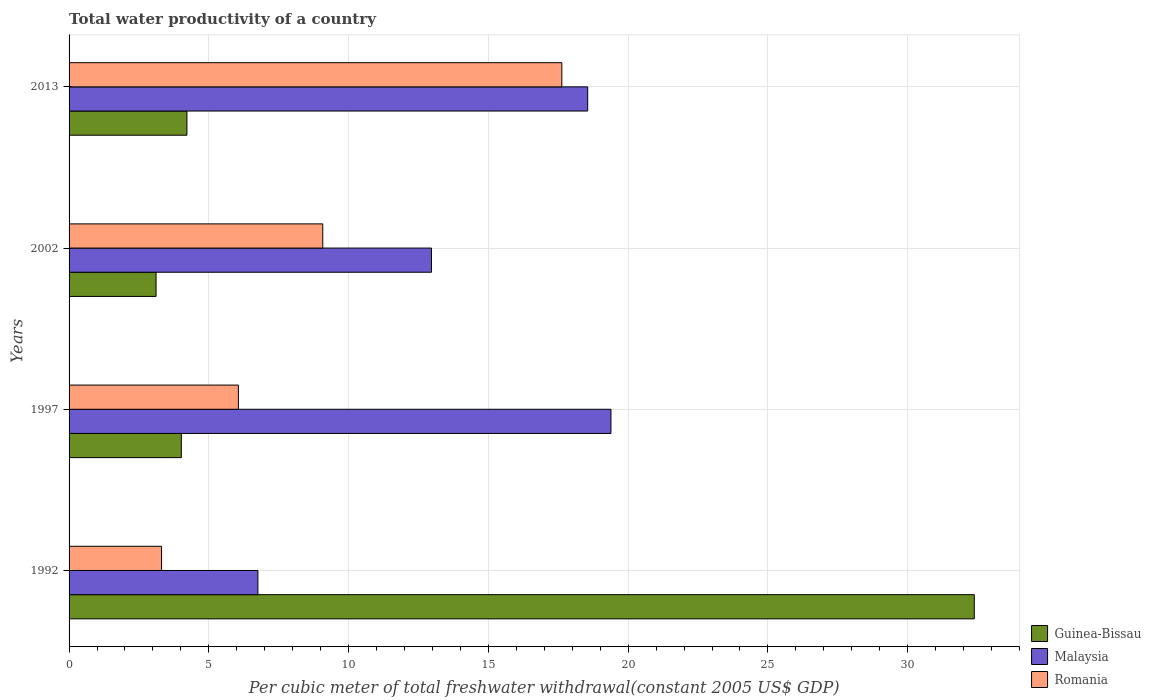How many different coloured bars are there?
Keep it short and to the point. 3. Are the number of bars per tick equal to the number of legend labels?
Your answer should be very brief. Yes. How many bars are there on the 4th tick from the top?
Your answer should be compact. 3. What is the total water productivity in Malaysia in 1997?
Your response must be concise. 19.38. Across all years, what is the maximum total water productivity in Malaysia?
Provide a short and direct response. 19.38. Across all years, what is the minimum total water productivity in Guinea-Bissau?
Your response must be concise. 3.11. In which year was the total water productivity in Romania maximum?
Your response must be concise. 2013. What is the total total water productivity in Malaysia in the graph?
Your answer should be very brief. 57.66. What is the difference between the total water productivity in Romania in 1997 and that in 2002?
Give a very brief answer. -3.02. What is the difference between the total water productivity in Romania in 2013 and the total water productivity in Guinea-Bissau in 2002?
Offer a terse response. 14.52. What is the average total water productivity in Romania per year?
Your answer should be very brief. 9.02. In the year 2002, what is the difference between the total water productivity in Guinea-Bissau and total water productivity in Romania?
Ensure brevity in your answer.  -5.96. In how many years, is the total water productivity in Guinea-Bissau greater than 26 US$?
Make the answer very short. 1. What is the ratio of the total water productivity in Guinea-Bissau in 1992 to that in 1997?
Your response must be concise. 8.06. Is the total water productivity in Guinea-Bissau in 1992 less than that in 2013?
Provide a succinct answer. No. What is the difference between the highest and the second highest total water productivity in Guinea-Bissau?
Make the answer very short. 28.17. What is the difference between the highest and the lowest total water productivity in Guinea-Bissau?
Your answer should be compact. 29.27. Is the sum of the total water productivity in Romania in 1992 and 1997 greater than the maximum total water productivity in Guinea-Bissau across all years?
Provide a succinct answer. No. What does the 3rd bar from the top in 2002 represents?
Provide a succinct answer. Guinea-Bissau. What does the 2nd bar from the bottom in 1992 represents?
Your answer should be compact. Malaysia. Are all the bars in the graph horizontal?
Keep it short and to the point. Yes. What is the difference between two consecutive major ticks on the X-axis?
Provide a short and direct response. 5. Does the graph contain any zero values?
Your response must be concise. No. Does the graph contain grids?
Provide a short and direct response. Yes. Where does the legend appear in the graph?
Your answer should be very brief. Bottom right. How many legend labels are there?
Your response must be concise. 3. How are the legend labels stacked?
Make the answer very short. Vertical. What is the title of the graph?
Your answer should be compact. Total water productivity of a country. What is the label or title of the X-axis?
Provide a short and direct response. Per cubic meter of total freshwater withdrawal(constant 2005 US$ GDP). What is the Per cubic meter of total freshwater withdrawal(constant 2005 US$ GDP) of Guinea-Bissau in 1992?
Make the answer very short. 32.38. What is the Per cubic meter of total freshwater withdrawal(constant 2005 US$ GDP) in Malaysia in 1992?
Provide a succinct answer. 6.76. What is the Per cubic meter of total freshwater withdrawal(constant 2005 US$ GDP) of Romania in 1992?
Your answer should be very brief. 3.31. What is the Per cubic meter of total freshwater withdrawal(constant 2005 US$ GDP) in Guinea-Bissau in 1997?
Provide a succinct answer. 4.02. What is the Per cubic meter of total freshwater withdrawal(constant 2005 US$ GDP) in Malaysia in 1997?
Offer a very short reply. 19.38. What is the Per cubic meter of total freshwater withdrawal(constant 2005 US$ GDP) of Romania in 1997?
Provide a short and direct response. 6.06. What is the Per cubic meter of total freshwater withdrawal(constant 2005 US$ GDP) in Guinea-Bissau in 2002?
Provide a short and direct response. 3.11. What is the Per cubic meter of total freshwater withdrawal(constant 2005 US$ GDP) of Malaysia in 2002?
Offer a terse response. 12.96. What is the Per cubic meter of total freshwater withdrawal(constant 2005 US$ GDP) in Romania in 2002?
Your answer should be compact. 9.08. What is the Per cubic meter of total freshwater withdrawal(constant 2005 US$ GDP) of Guinea-Bissau in 2013?
Keep it short and to the point. 4.22. What is the Per cubic meter of total freshwater withdrawal(constant 2005 US$ GDP) in Malaysia in 2013?
Your answer should be compact. 18.55. What is the Per cubic meter of total freshwater withdrawal(constant 2005 US$ GDP) in Romania in 2013?
Offer a very short reply. 17.63. Across all years, what is the maximum Per cubic meter of total freshwater withdrawal(constant 2005 US$ GDP) in Guinea-Bissau?
Ensure brevity in your answer.  32.38. Across all years, what is the maximum Per cubic meter of total freshwater withdrawal(constant 2005 US$ GDP) of Malaysia?
Your answer should be compact. 19.38. Across all years, what is the maximum Per cubic meter of total freshwater withdrawal(constant 2005 US$ GDP) in Romania?
Provide a succinct answer. 17.63. Across all years, what is the minimum Per cubic meter of total freshwater withdrawal(constant 2005 US$ GDP) in Guinea-Bissau?
Keep it short and to the point. 3.11. Across all years, what is the minimum Per cubic meter of total freshwater withdrawal(constant 2005 US$ GDP) in Malaysia?
Make the answer very short. 6.76. Across all years, what is the minimum Per cubic meter of total freshwater withdrawal(constant 2005 US$ GDP) in Romania?
Offer a very short reply. 3.31. What is the total Per cubic meter of total freshwater withdrawal(constant 2005 US$ GDP) of Guinea-Bissau in the graph?
Offer a very short reply. 43.73. What is the total Per cubic meter of total freshwater withdrawal(constant 2005 US$ GDP) in Malaysia in the graph?
Offer a very short reply. 57.66. What is the total Per cubic meter of total freshwater withdrawal(constant 2005 US$ GDP) of Romania in the graph?
Offer a terse response. 36.07. What is the difference between the Per cubic meter of total freshwater withdrawal(constant 2005 US$ GDP) in Guinea-Bissau in 1992 and that in 1997?
Provide a succinct answer. 28.37. What is the difference between the Per cubic meter of total freshwater withdrawal(constant 2005 US$ GDP) in Malaysia in 1992 and that in 1997?
Ensure brevity in your answer.  -12.63. What is the difference between the Per cubic meter of total freshwater withdrawal(constant 2005 US$ GDP) in Romania in 1992 and that in 1997?
Make the answer very short. -2.75. What is the difference between the Per cubic meter of total freshwater withdrawal(constant 2005 US$ GDP) of Guinea-Bissau in 1992 and that in 2002?
Make the answer very short. 29.27. What is the difference between the Per cubic meter of total freshwater withdrawal(constant 2005 US$ GDP) in Malaysia in 1992 and that in 2002?
Offer a very short reply. -6.21. What is the difference between the Per cubic meter of total freshwater withdrawal(constant 2005 US$ GDP) of Romania in 1992 and that in 2002?
Offer a very short reply. -5.77. What is the difference between the Per cubic meter of total freshwater withdrawal(constant 2005 US$ GDP) of Guinea-Bissau in 1992 and that in 2013?
Give a very brief answer. 28.17. What is the difference between the Per cubic meter of total freshwater withdrawal(constant 2005 US$ GDP) of Malaysia in 1992 and that in 2013?
Give a very brief answer. -11.8. What is the difference between the Per cubic meter of total freshwater withdrawal(constant 2005 US$ GDP) of Romania in 1992 and that in 2013?
Offer a very short reply. -14.32. What is the difference between the Per cubic meter of total freshwater withdrawal(constant 2005 US$ GDP) of Guinea-Bissau in 1997 and that in 2002?
Your answer should be very brief. 0.9. What is the difference between the Per cubic meter of total freshwater withdrawal(constant 2005 US$ GDP) of Malaysia in 1997 and that in 2002?
Offer a very short reply. 6.42. What is the difference between the Per cubic meter of total freshwater withdrawal(constant 2005 US$ GDP) of Romania in 1997 and that in 2002?
Ensure brevity in your answer.  -3.02. What is the difference between the Per cubic meter of total freshwater withdrawal(constant 2005 US$ GDP) of Guinea-Bissau in 1997 and that in 2013?
Provide a succinct answer. -0.2. What is the difference between the Per cubic meter of total freshwater withdrawal(constant 2005 US$ GDP) in Malaysia in 1997 and that in 2013?
Ensure brevity in your answer.  0.83. What is the difference between the Per cubic meter of total freshwater withdrawal(constant 2005 US$ GDP) of Romania in 1997 and that in 2013?
Your answer should be compact. -11.57. What is the difference between the Per cubic meter of total freshwater withdrawal(constant 2005 US$ GDP) in Guinea-Bissau in 2002 and that in 2013?
Keep it short and to the point. -1.1. What is the difference between the Per cubic meter of total freshwater withdrawal(constant 2005 US$ GDP) of Malaysia in 2002 and that in 2013?
Your answer should be compact. -5.59. What is the difference between the Per cubic meter of total freshwater withdrawal(constant 2005 US$ GDP) of Romania in 2002 and that in 2013?
Ensure brevity in your answer.  -8.55. What is the difference between the Per cubic meter of total freshwater withdrawal(constant 2005 US$ GDP) in Guinea-Bissau in 1992 and the Per cubic meter of total freshwater withdrawal(constant 2005 US$ GDP) in Malaysia in 1997?
Provide a short and direct response. 13. What is the difference between the Per cubic meter of total freshwater withdrawal(constant 2005 US$ GDP) in Guinea-Bissau in 1992 and the Per cubic meter of total freshwater withdrawal(constant 2005 US$ GDP) in Romania in 1997?
Provide a succinct answer. 26.33. What is the difference between the Per cubic meter of total freshwater withdrawal(constant 2005 US$ GDP) of Malaysia in 1992 and the Per cubic meter of total freshwater withdrawal(constant 2005 US$ GDP) of Romania in 1997?
Your answer should be very brief. 0.7. What is the difference between the Per cubic meter of total freshwater withdrawal(constant 2005 US$ GDP) of Guinea-Bissau in 1992 and the Per cubic meter of total freshwater withdrawal(constant 2005 US$ GDP) of Malaysia in 2002?
Keep it short and to the point. 19.42. What is the difference between the Per cubic meter of total freshwater withdrawal(constant 2005 US$ GDP) in Guinea-Bissau in 1992 and the Per cubic meter of total freshwater withdrawal(constant 2005 US$ GDP) in Romania in 2002?
Give a very brief answer. 23.31. What is the difference between the Per cubic meter of total freshwater withdrawal(constant 2005 US$ GDP) of Malaysia in 1992 and the Per cubic meter of total freshwater withdrawal(constant 2005 US$ GDP) of Romania in 2002?
Keep it short and to the point. -2.32. What is the difference between the Per cubic meter of total freshwater withdrawal(constant 2005 US$ GDP) of Guinea-Bissau in 1992 and the Per cubic meter of total freshwater withdrawal(constant 2005 US$ GDP) of Malaysia in 2013?
Provide a short and direct response. 13.83. What is the difference between the Per cubic meter of total freshwater withdrawal(constant 2005 US$ GDP) of Guinea-Bissau in 1992 and the Per cubic meter of total freshwater withdrawal(constant 2005 US$ GDP) of Romania in 2013?
Make the answer very short. 14.75. What is the difference between the Per cubic meter of total freshwater withdrawal(constant 2005 US$ GDP) in Malaysia in 1992 and the Per cubic meter of total freshwater withdrawal(constant 2005 US$ GDP) in Romania in 2013?
Your response must be concise. -10.87. What is the difference between the Per cubic meter of total freshwater withdrawal(constant 2005 US$ GDP) in Guinea-Bissau in 1997 and the Per cubic meter of total freshwater withdrawal(constant 2005 US$ GDP) in Malaysia in 2002?
Ensure brevity in your answer.  -8.95. What is the difference between the Per cubic meter of total freshwater withdrawal(constant 2005 US$ GDP) in Guinea-Bissau in 1997 and the Per cubic meter of total freshwater withdrawal(constant 2005 US$ GDP) in Romania in 2002?
Ensure brevity in your answer.  -5.06. What is the difference between the Per cubic meter of total freshwater withdrawal(constant 2005 US$ GDP) of Malaysia in 1997 and the Per cubic meter of total freshwater withdrawal(constant 2005 US$ GDP) of Romania in 2002?
Offer a terse response. 10.31. What is the difference between the Per cubic meter of total freshwater withdrawal(constant 2005 US$ GDP) of Guinea-Bissau in 1997 and the Per cubic meter of total freshwater withdrawal(constant 2005 US$ GDP) of Malaysia in 2013?
Your answer should be very brief. -14.54. What is the difference between the Per cubic meter of total freshwater withdrawal(constant 2005 US$ GDP) in Guinea-Bissau in 1997 and the Per cubic meter of total freshwater withdrawal(constant 2005 US$ GDP) in Romania in 2013?
Ensure brevity in your answer.  -13.61. What is the difference between the Per cubic meter of total freshwater withdrawal(constant 2005 US$ GDP) of Malaysia in 1997 and the Per cubic meter of total freshwater withdrawal(constant 2005 US$ GDP) of Romania in 2013?
Offer a very short reply. 1.76. What is the difference between the Per cubic meter of total freshwater withdrawal(constant 2005 US$ GDP) in Guinea-Bissau in 2002 and the Per cubic meter of total freshwater withdrawal(constant 2005 US$ GDP) in Malaysia in 2013?
Ensure brevity in your answer.  -15.44. What is the difference between the Per cubic meter of total freshwater withdrawal(constant 2005 US$ GDP) in Guinea-Bissau in 2002 and the Per cubic meter of total freshwater withdrawal(constant 2005 US$ GDP) in Romania in 2013?
Offer a very short reply. -14.52. What is the difference between the Per cubic meter of total freshwater withdrawal(constant 2005 US$ GDP) of Malaysia in 2002 and the Per cubic meter of total freshwater withdrawal(constant 2005 US$ GDP) of Romania in 2013?
Your answer should be compact. -4.66. What is the average Per cubic meter of total freshwater withdrawal(constant 2005 US$ GDP) in Guinea-Bissau per year?
Keep it short and to the point. 10.93. What is the average Per cubic meter of total freshwater withdrawal(constant 2005 US$ GDP) in Malaysia per year?
Provide a short and direct response. 14.41. What is the average Per cubic meter of total freshwater withdrawal(constant 2005 US$ GDP) in Romania per year?
Provide a short and direct response. 9.02. In the year 1992, what is the difference between the Per cubic meter of total freshwater withdrawal(constant 2005 US$ GDP) of Guinea-Bissau and Per cubic meter of total freshwater withdrawal(constant 2005 US$ GDP) of Malaysia?
Provide a short and direct response. 25.63. In the year 1992, what is the difference between the Per cubic meter of total freshwater withdrawal(constant 2005 US$ GDP) of Guinea-Bissau and Per cubic meter of total freshwater withdrawal(constant 2005 US$ GDP) of Romania?
Offer a very short reply. 29.07. In the year 1992, what is the difference between the Per cubic meter of total freshwater withdrawal(constant 2005 US$ GDP) in Malaysia and Per cubic meter of total freshwater withdrawal(constant 2005 US$ GDP) in Romania?
Offer a terse response. 3.45. In the year 1997, what is the difference between the Per cubic meter of total freshwater withdrawal(constant 2005 US$ GDP) in Guinea-Bissau and Per cubic meter of total freshwater withdrawal(constant 2005 US$ GDP) in Malaysia?
Keep it short and to the point. -15.37. In the year 1997, what is the difference between the Per cubic meter of total freshwater withdrawal(constant 2005 US$ GDP) of Guinea-Bissau and Per cubic meter of total freshwater withdrawal(constant 2005 US$ GDP) of Romania?
Offer a terse response. -2.04. In the year 1997, what is the difference between the Per cubic meter of total freshwater withdrawal(constant 2005 US$ GDP) in Malaysia and Per cubic meter of total freshwater withdrawal(constant 2005 US$ GDP) in Romania?
Keep it short and to the point. 13.33. In the year 2002, what is the difference between the Per cubic meter of total freshwater withdrawal(constant 2005 US$ GDP) of Guinea-Bissau and Per cubic meter of total freshwater withdrawal(constant 2005 US$ GDP) of Malaysia?
Your response must be concise. -9.85. In the year 2002, what is the difference between the Per cubic meter of total freshwater withdrawal(constant 2005 US$ GDP) in Guinea-Bissau and Per cubic meter of total freshwater withdrawal(constant 2005 US$ GDP) in Romania?
Provide a short and direct response. -5.96. In the year 2002, what is the difference between the Per cubic meter of total freshwater withdrawal(constant 2005 US$ GDP) of Malaysia and Per cubic meter of total freshwater withdrawal(constant 2005 US$ GDP) of Romania?
Make the answer very short. 3.89. In the year 2013, what is the difference between the Per cubic meter of total freshwater withdrawal(constant 2005 US$ GDP) in Guinea-Bissau and Per cubic meter of total freshwater withdrawal(constant 2005 US$ GDP) in Malaysia?
Give a very brief answer. -14.34. In the year 2013, what is the difference between the Per cubic meter of total freshwater withdrawal(constant 2005 US$ GDP) in Guinea-Bissau and Per cubic meter of total freshwater withdrawal(constant 2005 US$ GDP) in Romania?
Provide a short and direct response. -13.41. In the year 2013, what is the difference between the Per cubic meter of total freshwater withdrawal(constant 2005 US$ GDP) in Malaysia and Per cubic meter of total freshwater withdrawal(constant 2005 US$ GDP) in Romania?
Offer a terse response. 0.92. What is the ratio of the Per cubic meter of total freshwater withdrawal(constant 2005 US$ GDP) in Guinea-Bissau in 1992 to that in 1997?
Your answer should be very brief. 8.06. What is the ratio of the Per cubic meter of total freshwater withdrawal(constant 2005 US$ GDP) in Malaysia in 1992 to that in 1997?
Ensure brevity in your answer.  0.35. What is the ratio of the Per cubic meter of total freshwater withdrawal(constant 2005 US$ GDP) in Romania in 1992 to that in 1997?
Keep it short and to the point. 0.55. What is the ratio of the Per cubic meter of total freshwater withdrawal(constant 2005 US$ GDP) in Guinea-Bissau in 1992 to that in 2002?
Provide a succinct answer. 10.41. What is the ratio of the Per cubic meter of total freshwater withdrawal(constant 2005 US$ GDP) of Malaysia in 1992 to that in 2002?
Your response must be concise. 0.52. What is the ratio of the Per cubic meter of total freshwater withdrawal(constant 2005 US$ GDP) of Romania in 1992 to that in 2002?
Your answer should be very brief. 0.36. What is the ratio of the Per cubic meter of total freshwater withdrawal(constant 2005 US$ GDP) of Guinea-Bissau in 1992 to that in 2013?
Your answer should be compact. 7.68. What is the ratio of the Per cubic meter of total freshwater withdrawal(constant 2005 US$ GDP) in Malaysia in 1992 to that in 2013?
Your answer should be very brief. 0.36. What is the ratio of the Per cubic meter of total freshwater withdrawal(constant 2005 US$ GDP) in Romania in 1992 to that in 2013?
Your answer should be compact. 0.19. What is the ratio of the Per cubic meter of total freshwater withdrawal(constant 2005 US$ GDP) of Guinea-Bissau in 1997 to that in 2002?
Give a very brief answer. 1.29. What is the ratio of the Per cubic meter of total freshwater withdrawal(constant 2005 US$ GDP) of Malaysia in 1997 to that in 2002?
Your answer should be compact. 1.5. What is the ratio of the Per cubic meter of total freshwater withdrawal(constant 2005 US$ GDP) of Romania in 1997 to that in 2002?
Make the answer very short. 0.67. What is the ratio of the Per cubic meter of total freshwater withdrawal(constant 2005 US$ GDP) of Guinea-Bissau in 1997 to that in 2013?
Your answer should be compact. 0.95. What is the ratio of the Per cubic meter of total freshwater withdrawal(constant 2005 US$ GDP) of Malaysia in 1997 to that in 2013?
Keep it short and to the point. 1.04. What is the ratio of the Per cubic meter of total freshwater withdrawal(constant 2005 US$ GDP) of Romania in 1997 to that in 2013?
Your response must be concise. 0.34. What is the ratio of the Per cubic meter of total freshwater withdrawal(constant 2005 US$ GDP) of Guinea-Bissau in 2002 to that in 2013?
Provide a succinct answer. 0.74. What is the ratio of the Per cubic meter of total freshwater withdrawal(constant 2005 US$ GDP) in Malaysia in 2002 to that in 2013?
Your response must be concise. 0.7. What is the ratio of the Per cubic meter of total freshwater withdrawal(constant 2005 US$ GDP) of Romania in 2002 to that in 2013?
Your answer should be very brief. 0.51. What is the difference between the highest and the second highest Per cubic meter of total freshwater withdrawal(constant 2005 US$ GDP) in Guinea-Bissau?
Give a very brief answer. 28.17. What is the difference between the highest and the second highest Per cubic meter of total freshwater withdrawal(constant 2005 US$ GDP) of Malaysia?
Provide a succinct answer. 0.83. What is the difference between the highest and the second highest Per cubic meter of total freshwater withdrawal(constant 2005 US$ GDP) in Romania?
Provide a succinct answer. 8.55. What is the difference between the highest and the lowest Per cubic meter of total freshwater withdrawal(constant 2005 US$ GDP) in Guinea-Bissau?
Provide a succinct answer. 29.27. What is the difference between the highest and the lowest Per cubic meter of total freshwater withdrawal(constant 2005 US$ GDP) of Malaysia?
Your response must be concise. 12.63. What is the difference between the highest and the lowest Per cubic meter of total freshwater withdrawal(constant 2005 US$ GDP) of Romania?
Your answer should be compact. 14.32. 